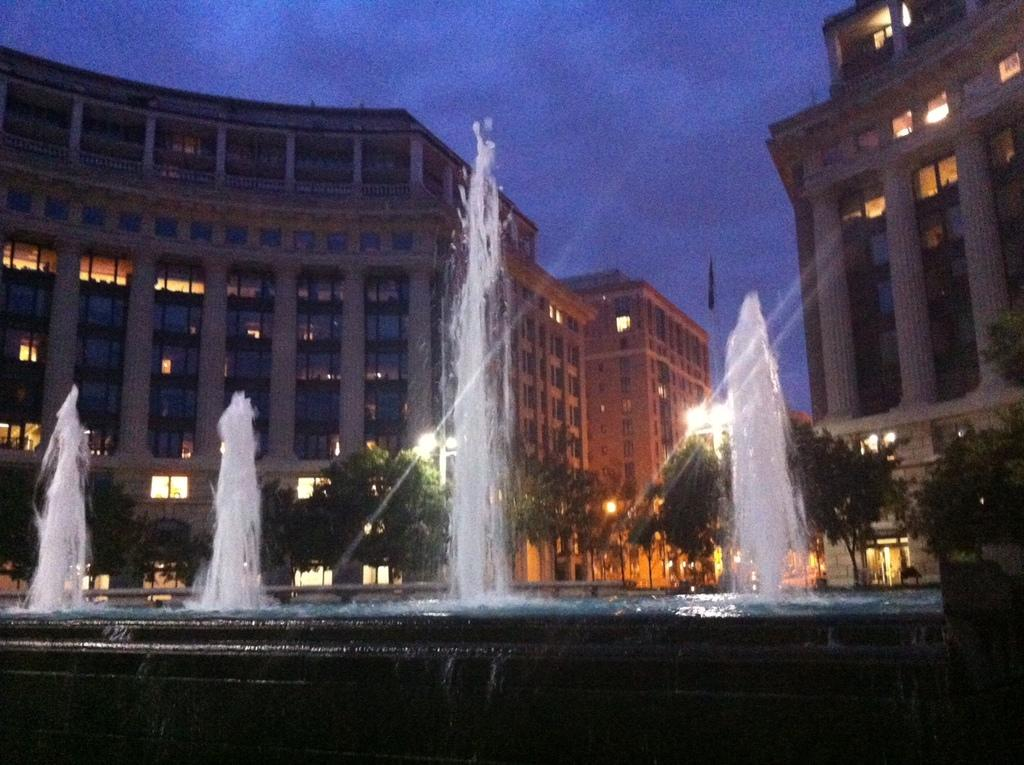What is the main feature in the image? There is a fountain in the image. What can be seen behind the fountain? There are trees and buildings behind the fountain. Are there any light sources visible in the image? Yes, there are lights visible in the image. What is visible at the top of the image? The sky is visible at the top of the image. What type of clock is hanging from the tree in the image? There is no clock present in the image; it features a fountain with trees and buildings in the background. Can you describe the flower that is growing near the fountain? There is no flower visible in the image; it only shows a fountain, trees, buildings, lights, and the sky. 